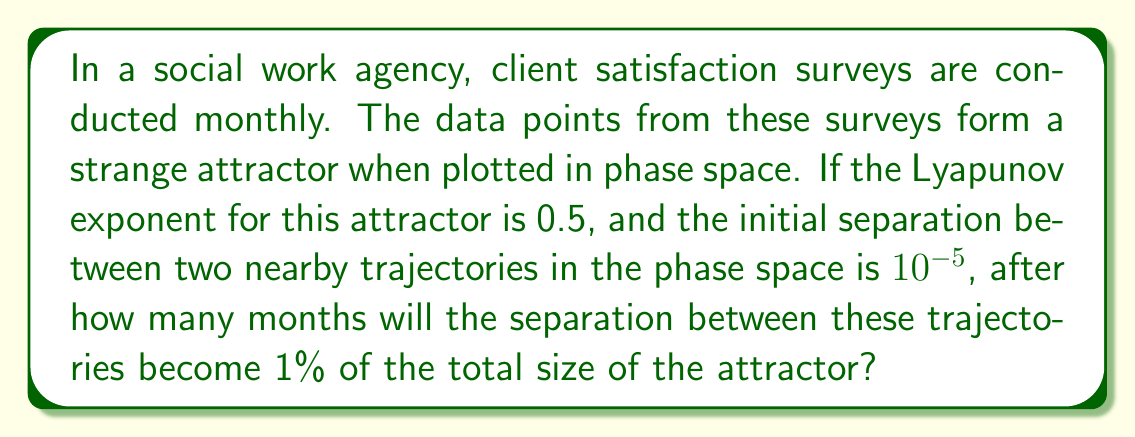Could you help me with this problem? To solve this problem, we'll use the properties of strange attractors and the Lyapunov exponent:

1) The Lyapunov exponent (λ) measures the rate of separation of infinitesimally close trajectories. In this case, λ = 0.5.

2) The formula for the separation of trajectories over time is:

   $$d(t) = d_0 e^{\lambda t}$$

   Where $d_0$ is the initial separation, $t$ is time, and $d(t)$ is the separation at time $t$.

3) We're given that $d_0 = 10^{-5}$ and we want to find $t$ when $d(t) = 0.01$ (1% of the attractor size).

4) Substituting these values into the equation:

   $$0.01 = 10^{-5} e^{0.5t}$$

5) Dividing both sides by $10^{-5}$:

   $$1000 = e^{0.5t}$$

6) Taking the natural log of both sides:

   $$\ln(1000) = 0.5t$$

7) Solving for $t$:

   $$t = \frac{\ln(1000)}{0.5} \approx 13.86$$

8) Since we're dealing with monthly surveys, we round up to the nearest whole number.
Answer: 14 months 